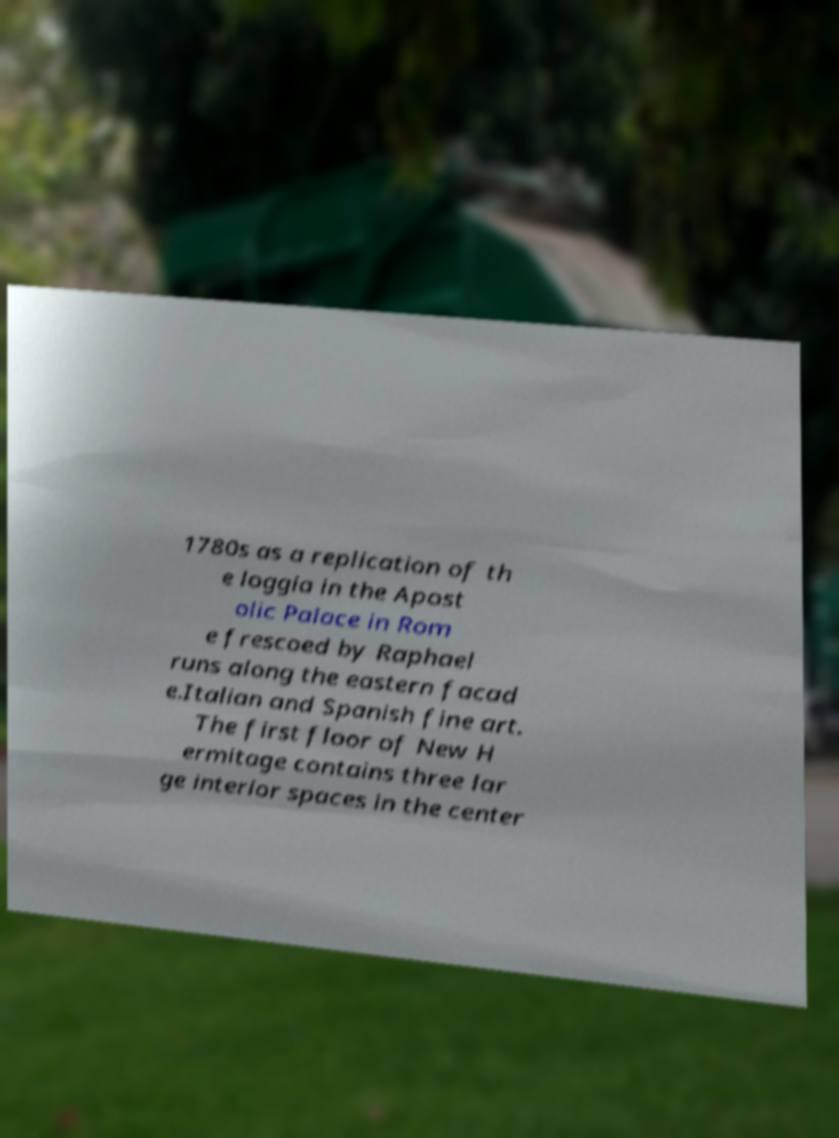What messages or text are displayed in this image? I need them in a readable, typed format. 1780s as a replication of th e loggia in the Apost olic Palace in Rom e frescoed by Raphael runs along the eastern facad e.Italian and Spanish fine art. The first floor of New H ermitage contains three lar ge interior spaces in the center 